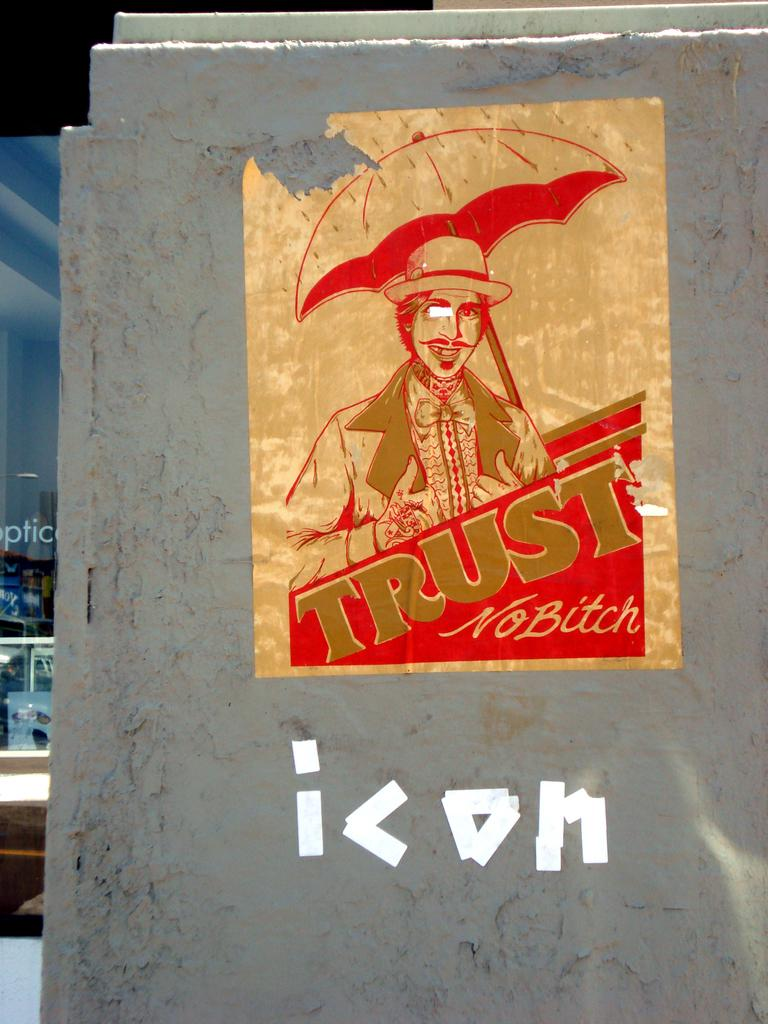<image>
Create a compact narrative representing the image presented. A sticker on a wall with an man holding an umbrella that says trust no bitch. 